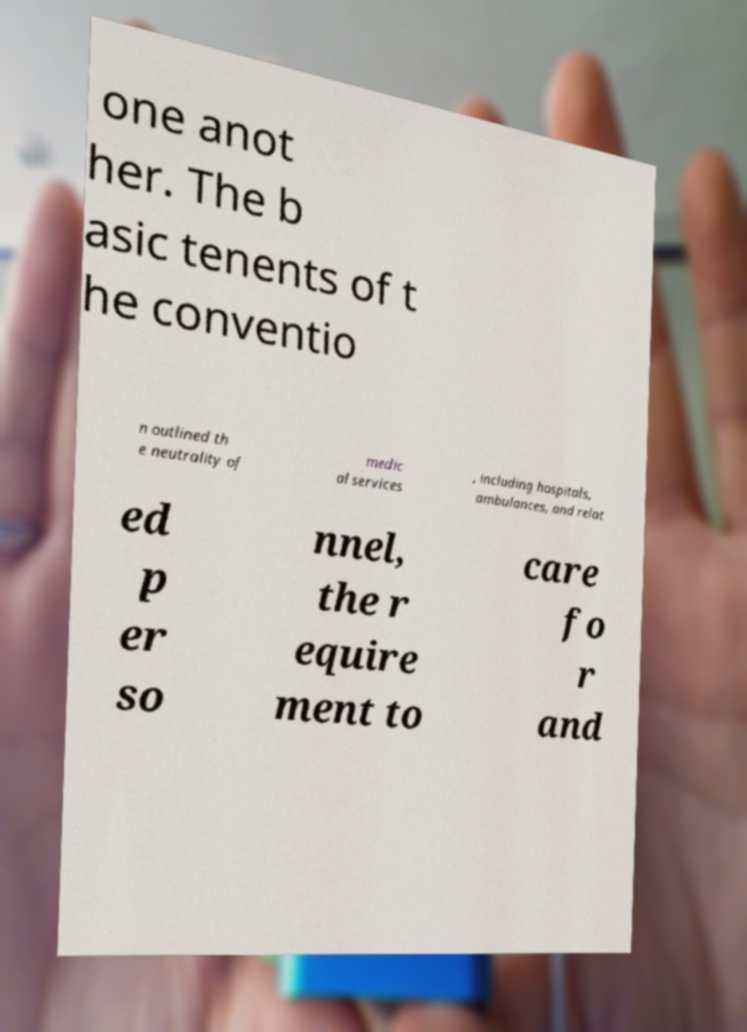Please identify and transcribe the text found in this image. one anot her. The b asic tenents of t he conventio n outlined th e neutrality of medic al services , including hospitals, ambulances, and relat ed p er so nnel, the r equire ment to care fo r and 